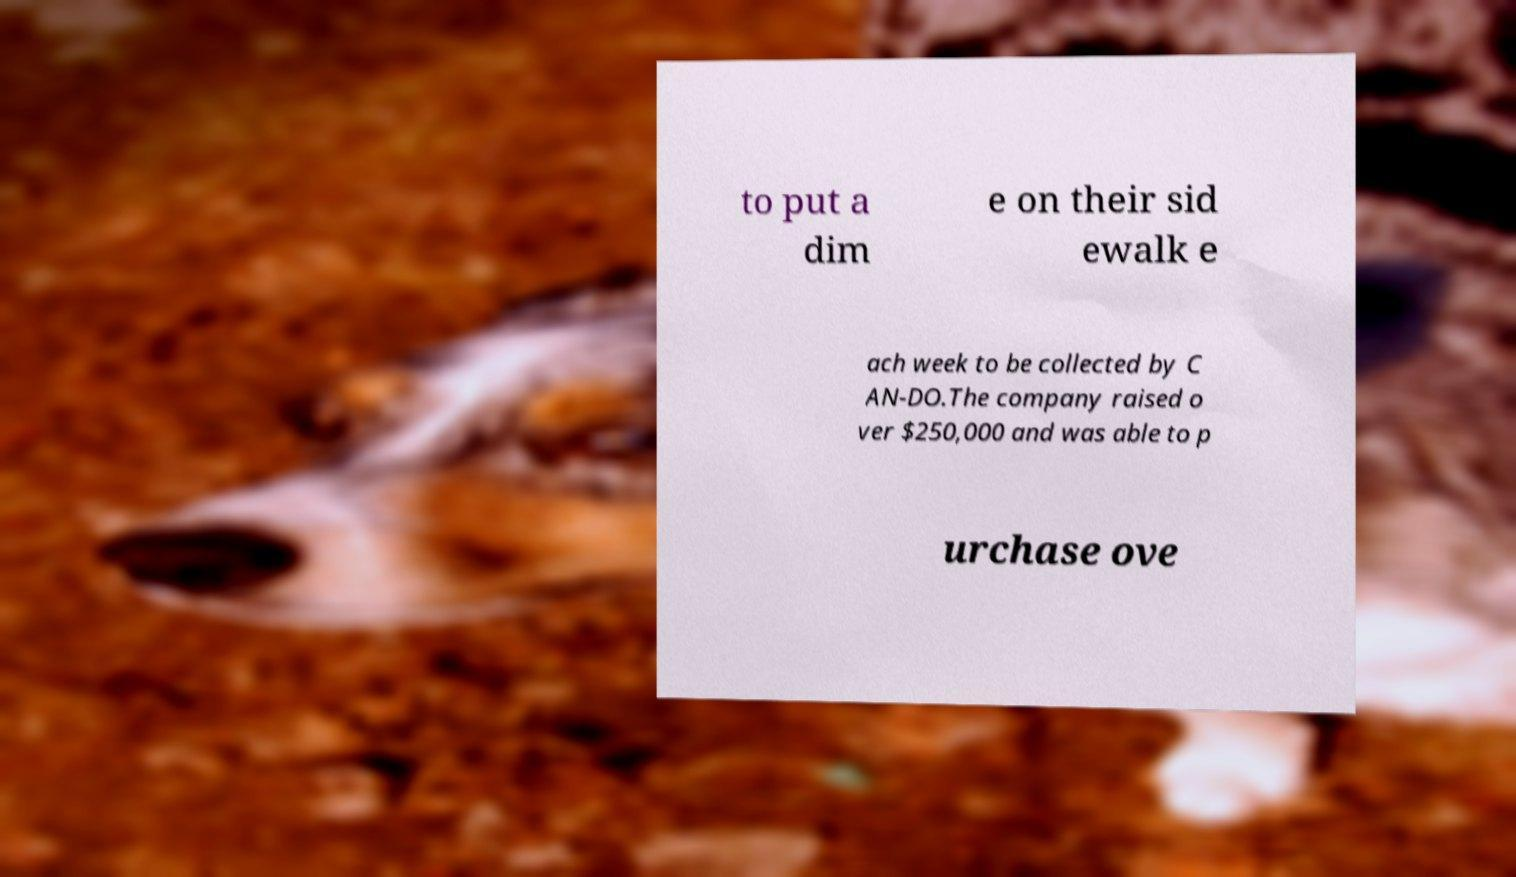Can you read and provide the text displayed in the image?This photo seems to have some interesting text. Can you extract and type it out for me? to put a dim e on their sid ewalk e ach week to be collected by C AN-DO.The company raised o ver $250,000 and was able to p urchase ove 